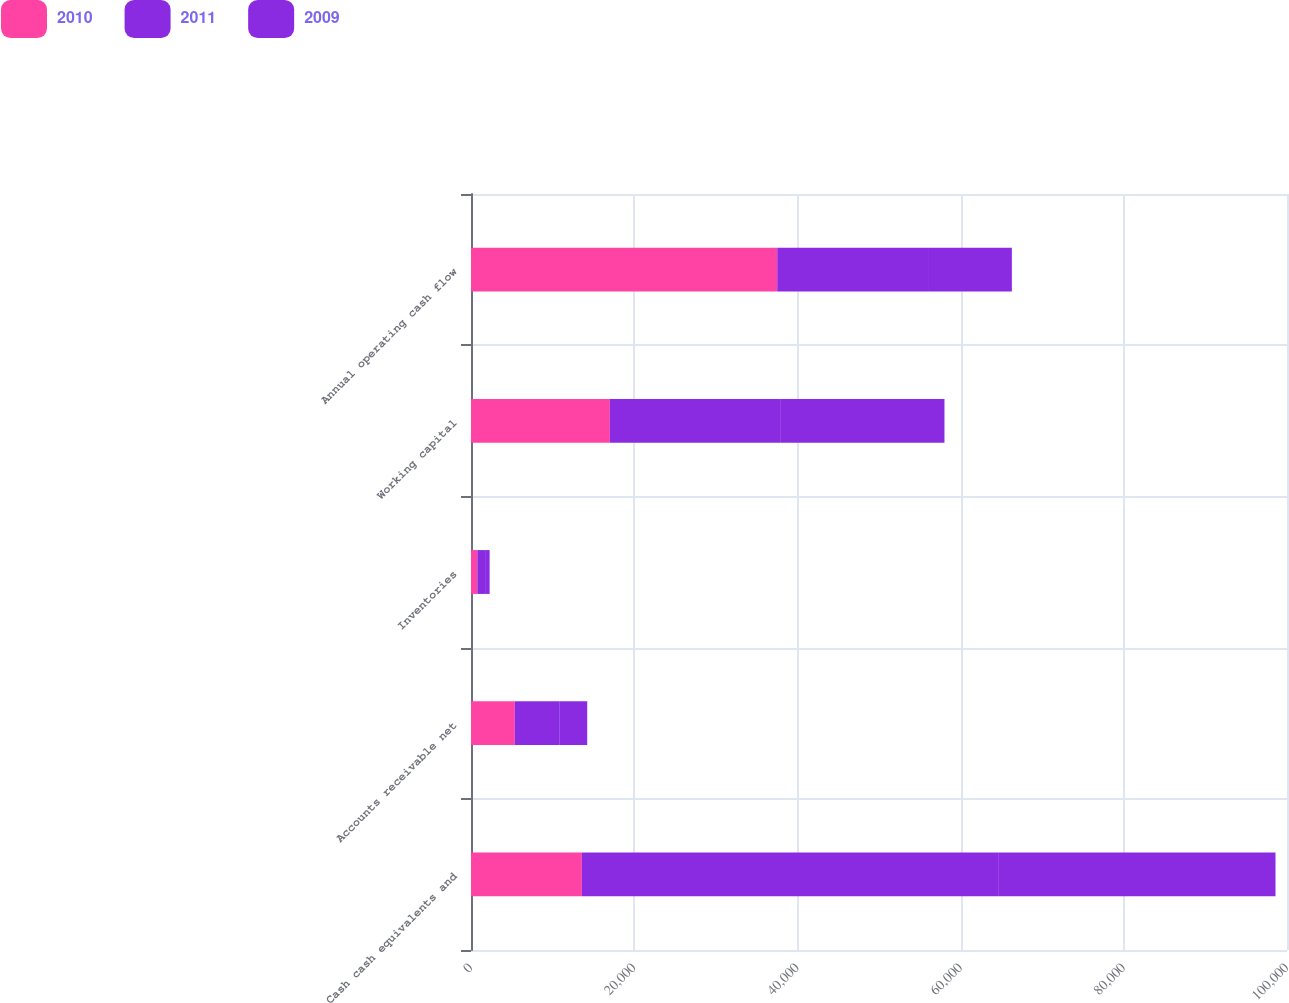Convert chart to OTSL. <chart><loc_0><loc_0><loc_500><loc_500><stacked_bar_chart><ecel><fcel>Cash cash equivalents and<fcel>Accounts receivable net<fcel>Inventories<fcel>Working capital<fcel>Annual operating cash flow<nl><fcel>2010<fcel>13588.5<fcel>5369<fcel>776<fcel>17018<fcel>37529<nl><fcel>2011<fcel>51011<fcel>5510<fcel>1051<fcel>20956<fcel>18595<nl><fcel>2009<fcel>33992<fcel>3361<fcel>455<fcel>20049<fcel>10159<nl></chart> 